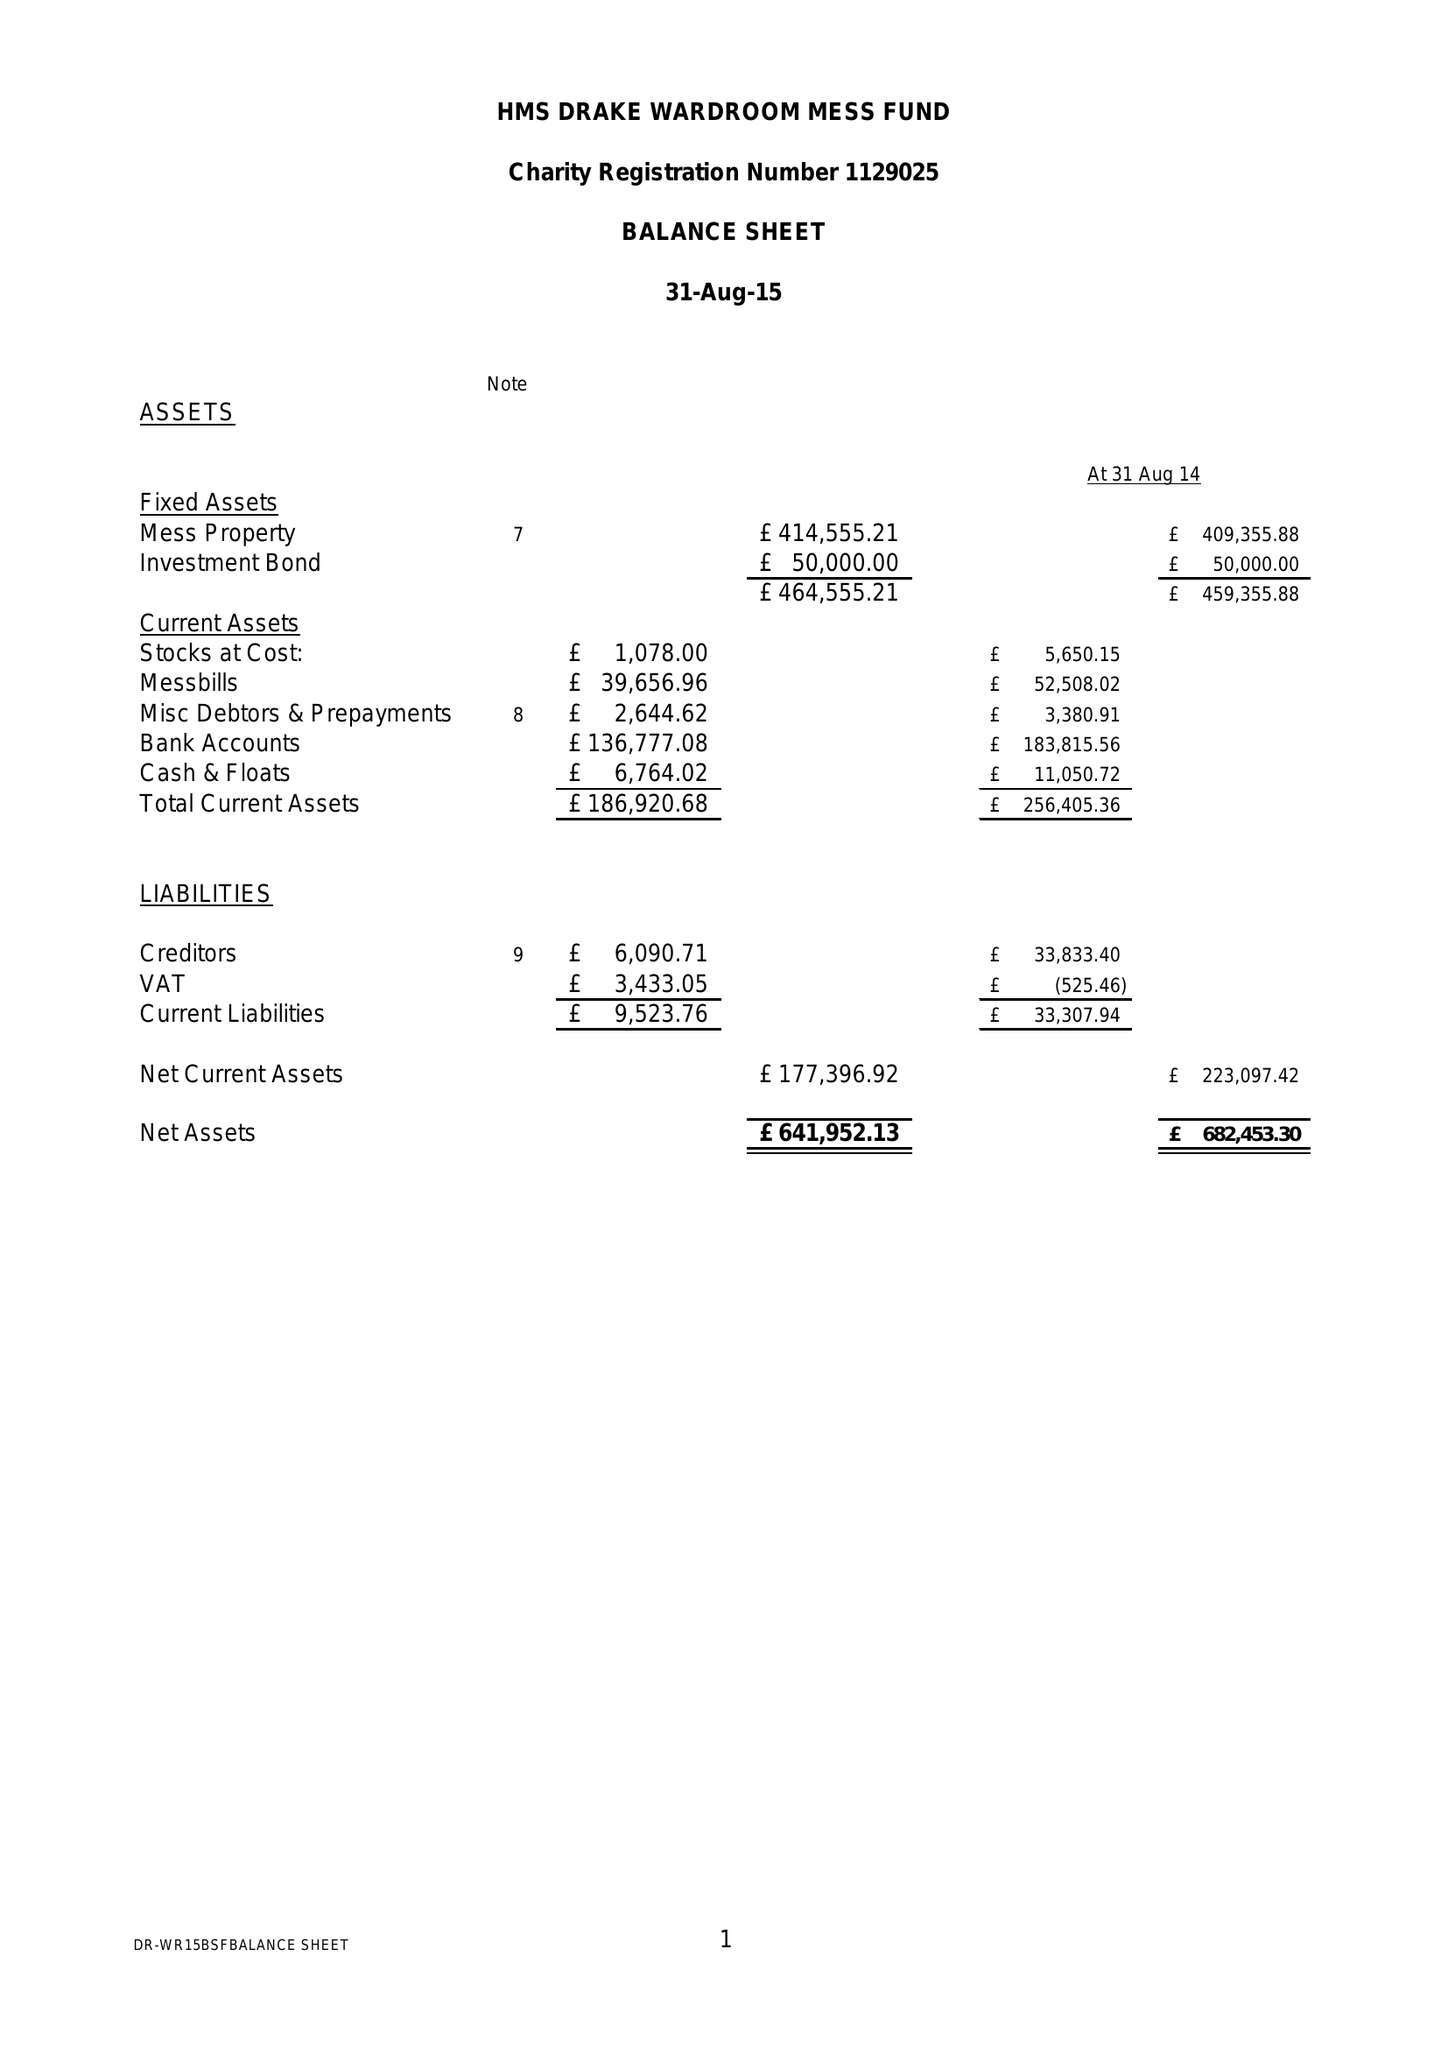What is the value for the address__post_town?
Answer the question using a single word or phrase. PLYMOUTH 